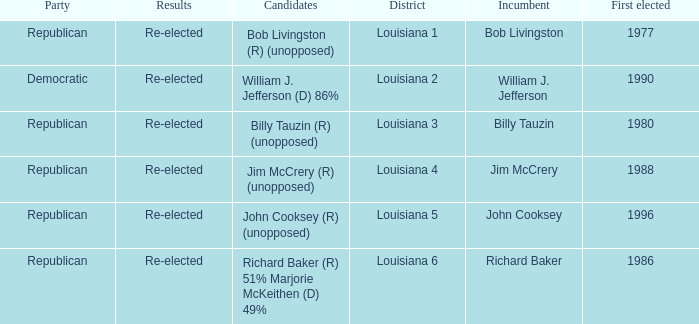Can you give me this table as a dict? {'header': ['Party', 'Results', 'Candidates', 'District', 'Incumbent', 'First elected'], 'rows': [['Republican', 'Re-elected', 'Bob Livingston (R) (unopposed)', 'Louisiana 1', 'Bob Livingston', '1977'], ['Democratic', 'Re-elected', 'William J. Jefferson (D) 86%', 'Louisiana 2', 'William J. Jefferson', '1990'], ['Republican', 'Re-elected', 'Billy Tauzin (R) (unopposed)', 'Louisiana 3', 'Billy Tauzin', '1980'], ['Republican', 'Re-elected', 'Jim McCrery (R) (unopposed)', 'Louisiana 4', 'Jim McCrery', '1988'], ['Republican', 'Re-elected', 'John Cooksey (R) (unopposed)', 'Louisiana 5', 'John Cooksey', '1996'], ['Republican', 'Re-elected', 'Richard Baker (R) 51% Marjorie McKeithen (D) 49%', 'Louisiana 6', 'Richard Baker', '1986']]} To which party is william j. jefferson affiliated? Democratic. 